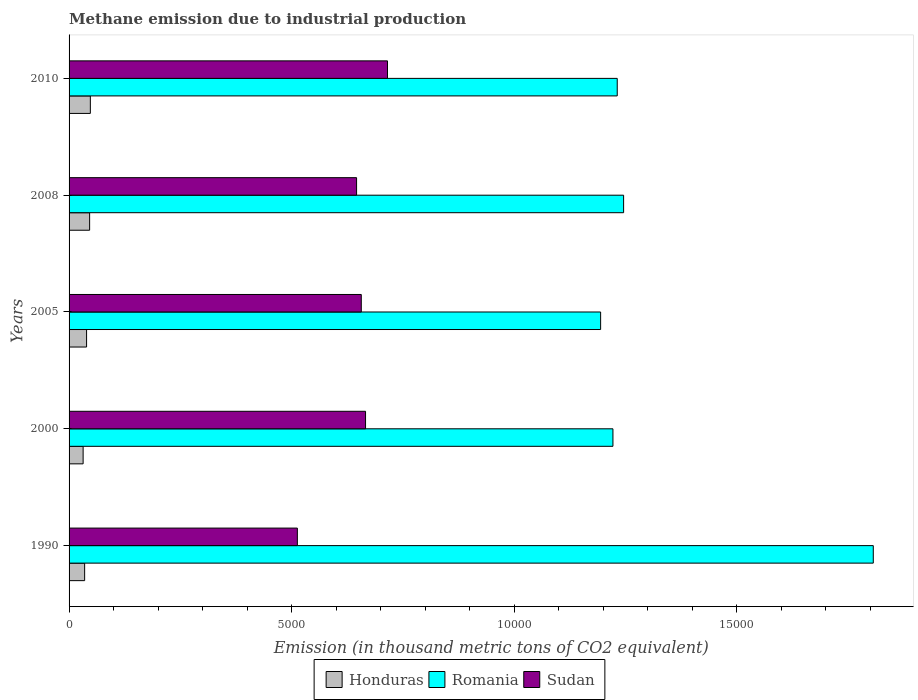How many different coloured bars are there?
Your answer should be compact. 3. Are the number of bars per tick equal to the number of legend labels?
Offer a very short reply. Yes. How many bars are there on the 5th tick from the bottom?
Your response must be concise. 3. What is the amount of methane emitted in Romania in 2010?
Give a very brief answer. 1.23e+04. Across all years, what is the maximum amount of methane emitted in Honduras?
Offer a terse response. 478.1. Across all years, what is the minimum amount of methane emitted in Honduras?
Give a very brief answer. 315.9. In which year was the amount of methane emitted in Romania minimum?
Your answer should be compact. 2005. What is the total amount of methane emitted in Sudan in the graph?
Provide a short and direct response. 3.20e+04. What is the difference between the amount of methane emitted in Honduras in 2000 and that in 2010?
Ensure brevity in your answer.  -162.2. What is the difference between the amount of methane emitted in Honduras in 2010 and the amount of methane emitted in Sudan in 2000?
Your answer should be very brief. -6182.8. What is the average amount of methane emitted in Romania per year?
Ensure brevity in your answer.  1.34e+04. In the year 2008, what is the difference between the amount of methane emitted in Sudan and amount of methane emitted in Romania?
Your answer should be compact. -5999.4. In how many years, is the amount of methane emitted in Sudan greater than 5000 thousand metric tons?
Your response must be concise. 5. What is the ratio of the amount of methane emitted in Honduras in 2005 to that in 2010?
Your answer should be compact. 0.82. Is the difference between the amount of methane emitted in Sudan in 2005 and 2010 greater than the difference between the amount of methane emitted in Romania in 2005 and 2010?
Give a very brief answer. No. What is the difference between the highest and the second highest amount of methane emitted in Romania?
Ensure brevity in your answer.  5609.2. What is the difference between the highest and the lowest amount of methane emitted in Sudan?
Ensure brevity in your answer.  2025. In how many years, is the amount of methane emitted in Romania greater than the average amount of methane emitted in Romania taken over all years?
Provide a short and direct response. 1. What does the 2nd bar from the top in 1990 represents?
Keep it short and to the point. Romania. What does the 3rd bar from the bottom in 2005 represents?
Your response must be concise. Sudan. Are all the bars in the graph horizontal?
Keep it short and to the point. Yes. What is the difference between two consecutive major ticks on the X-axis?
Ensure brevity in your answer.  5000. Are the values on the major ticks of X-axis written in scientific E-notation?
Provide a short and direct response. No. Does the graph contain grids?
Ensure brevity in your answer.  No. Where does the legend appear in the graph?
Your answer should be compact. Bottom center. How many legend labels are there?
Offer a very short reply. 3. How are the legend labels stacked?
Your answer should be compact. Horizontal. What is the title of the graph?
Your answer should be compact. Methane emission due to industrial production. What is the label or title of the X-axis?
Offer a terse response. Emission (in thousand metric tons of CO2 equivalent). What is the label or title of the Y-axis?
Your answer should be very brief. Years. What is the Emission (in thousand metric tons of CO2 equivalent) of Honduras in 1990?
Make the answer very short. 349.7. What is the Emission (in thousand metric tons of CO2 equivalent) in Romania in 1990?
Give a very brief answer. 1.81e+04. What is the Emission (in thousand metric tons of CO2 equivalent) of Sudan in 1990?
Your response must be concise. 5129.1. What is the Emission (in thousand metric tons of CO2 equivalent) in Honduras in 2000?
Your answer should be compact. 315.9. What is the Emission (in thousand metric tons of CO2 equivalent) of Romania in 2000?
Your answer should be compact. 1.22e+04. What is the Emission (in thousand metric tons of CO2 equivalent) in Sudan in 2000?
Offer a terse response. 6660.9. What is the Emission (in thousand metric tons of CO2 equivalent) of Honduras in 2005?
Your answer should be compact. 393.2. What is the Emission (in thousand metric tons of CO2 equivalent) of Romania in 2005?
Offer a very short reply. 1.19e+04. What is the Emission (in thousand metric tons of CO2 equivalent) in Sudan in 2005?
Your response must be concise. 6565.1. What is the Emission (in thousand metric tons of CO2 equivalent) of Honduras in 2008?
Provide a short and direct response. 461.7. What is the Emission (in thousand metric tons of CO2 equivalent) of Romania in 2008?
Your response must be concise. 1.25e+04. What is the Emission (in thousand metric tons of CO2 equivalent) in Sudan in 2008?
Your answer should be compact. 6459.5. What is the Emission (in thousand metric tons of CO2 equivalent) in Honduras in 2010?
Make the answer very short. 478.1. What is the Emission (in thousand metric tons of CO2 equivalent) in Romania in 2010?
Offer a very short reply. 1.23e+04. What is the Emission (in thousand metric tons of CO2 equivalent) in Sudan in 2010?
Keep it short and to the point. 7154.1. Across all years, what is the maximum Emission (in thousand metric tons of CO2 equivalent) of Honduras?
Give a very brief answer. 478.1. Across all years, what is the maximum Emission (in thousand metric tons of CO2 equivalent) in Romania?
Your answer should be very brief. 1.81e+04. Across all years, what is the maximum Emission (in thousand metric tons of CO2 equivalent) in Sudan?
Provide a short and direct response. 7154.1. Across all years, what is the minimum Emission (in thousand metric tons of CO2 equivalent) in Honduras?
Provide a succinct answer. 315.9. Across all years, what is the minimum Emission (in thousand metric tons of CO2 equivalent) of Romania?
Your answer should be very brief. 1.19e+04. Across all years, what is the minimum Emission (in thousand metric tons of CO2 equivalent) in Sudan?
Make the answer very short. 5129.1. What is the total Emission (in thousand metric tons of CO2 equivalent) of Honduras in the graph?
Your response must be concise. 1998.6. What is the total Emission (in thousand metric tons of CO2 equivalent) of Romania in the graph?
Offer a terse response. 6.70e+04. What is the total Emission (in thousand metric tons of CO2 equivalent) in Sudan in the graph?
Your answer should be very brief. 3.20e+04. What is the difference between the Emission (in thousand metric tons of CO2 equivalent) of Honduras in 1990 and that in 2000?
Provide a short and direct response. 33.8. What is the difference between the Emission (in thousand metric tons of CO2 equivalent) of Romania in 1990 and that in 2000?
Offer a terse response. 5849.1. What is the difference between the Emission (in thousand metric tons of CO2 equivalent) of Sudan in 1990 and that in 2000?
Provide a succinct answer. -1531.8. What is the difference between the Emission (in thousand metric tons of CO2 equivalent) of Honduras in 1990 and that in 2005?
Your response must be concise. -43.5. What is the difference between the Emission (in thousand metric tons of CO2 equivalent) in Romania in 1990 and that in 2005?
Keep it short and to the point. 6125.7. What is the difference between the Emission (in thousand metric tons of CO2 equivalent) in Sudan in 1990 and that in 2005?
Make the answer very short. -1436. What is the difference between the Emission (in thousand metric tons of CO2 equivalent) of Honduras in 1990 and that in 2008?
Offer a very short reply. -112. What is the difference between the Emission (in thousand metric tons of CO2 equivalent) in Romania in 1990 and that in 2008?
Make the answer very short. 5609.2. What is the difference between the Emission (in thousand metric tons of CO2 equivalent) in Sudan in 1990 and that in 2008?
Your response must be concise. -1330.4. What is the difference between the Emission (in thousand metric tons of CO2 equivalent) of Honduras in 1990 and that in 2010?
Keep it short and to the point. -128.4. What is the difference between the Emission (in thousand metric tons of CO2 equivalent) of Romania in 1990 and that in 2010?
Your answer should be compact. 5752.5. What is the difference between the Emission (in thousand metric tons of CO2 equivalent) in Sudan in 1990 and that in 2010?
Give a very brief answer. -2025. What is the difference between the Emission (in thousand metric tons of CO2 equivalent) of Honduras in 2000 and that in 2005?
Give a very brief answer. -77.3. What is the difference between the Emission (in thousand metric tons of CO2 equivalent) of Romania in 2000 and that in 2005?
Provide a short and direct response. 276.6. What is the difference between the Emission (in thousand metric tons of CO2 equivalent) of Sudan in 2000 and that in 2005?
Offer a terse response. 95.8. What is the difference between the Emission (in thousand metric tons of CO2 equivalent) of Honduras in 2000 and that in 2008?
Provide a short and direct response. -145.8. What is the difference between the Emission (in thousand metric tons of CO2 equivalent) in Romania in 2000 and that in 2008?
Make the answer very short. -239.9. What is the difference between the Emission (in thousand metric tons of CO2 equivalent) of Sudan in 2000 and that in 2008?
Keep it short and to the point. 201.4. What is the difference between the Emission (in thousand metric tons of CO2 equivalent) in Honduras in 2000 and that in 2010?
Offer a terse response. -162.2. What is the difference between the Emission (in thousand metric tons of CO2 equivalent) of Romania in 2000 and that in 2010?
Your answer should be very brief. -96.6. What is the difference between the Emission (in thousand metric tons of CO2 equivalent) of Sudan in 2000 and that in 2010?
Your answer should be compact. -493.2. What is the difference between the Emission (in thousand metric tons of CO2 equivalent) of Honduras in 2005 and that in 2008?
Give a very brief answer. -68.5. What is the difference between the Emission (in thousand metric tons of CO2 equivalent) in Romania in 2005 and that in 2008?
Your answer should be compact. -516.5. What is the difference between the Emission (in thousand metric tons of CO2 equivalent) in Sudan in 2005 and that in 2008?
Your response must be concise. 105.6. What is the difference between the Emission (in thousand metric tons of CO2 equivalent) in Honduras in 2005 and that in 2010?
Ensure brevity in your answer.  -84.9. What is the difference between the Emission (in thousand metric tons of CO2 equivalent) in Romania in 2005 and that in 2010?
Your answer should be very brief. -373.2. What is the difference between the Emission (in thousand metric tons of CO2 equivalent) in Sudan in 2005 and that in 2010?
Your response must be concise. -589. What is the difference between the Emission (in thousand metric tons of CO2 equivalent) of Honduras in 2008 and that in 2010?
Your answer should be compact. -16.4. What is the difference between the Emission (in thousand metric tons of CO2 equivalent) in Romania in 2008 and that in 2010?
Your answer should be very brief. 143.3. What is the difference between the Emission (in thousand metric tons of CO2 equivalent) of Sudan in 2008 and that in 2010?
Your answer should be compact. -694.6. What is the difference between the Emission (in thousand metric tons of CO2 equivalent) in Honduras in 1990 and the Emission (in thousand metric tons of CO2 equivalent) in Romania in 2000?
Provide a short and direct response. -1.19e+04. What is the difference between the Emission (in thousand metric tons of CO2 equivalent) of Honduras in 1990 and the Emission (in thousand metric tons of CO2 equivalent) of Sudan in 2000?
Ensure brevity in your answer.  -6311.2. What is the difference between the Emission (in thousand metric tons of CO2 equivalent) of Romania in 1990 and the Emission (in thousand metric tons of CO2 equivalent) of Sudan in 2000?
Keep it short and to the point. 1.14e+04. What is the difference between the Emission (in thousand metric tons of CO2 equivalent) of Honduras in 1990 and the Emission (in thousand metric tons of CO2 equivalent) of Romania in 2005?
Ensure brevity in your answer.  -1.16e+04. What is the difference between the Emission (in thousand metric tons of CO2 equivalent) in Honduras in 1990 and the Emission (in thousand metric tons of CO2 equivalent) in Sudan in 2005?
Ensure brevity in your answer.  -6215.4. What is the difference between the Emission (in thousand metric tons of CO2 equivalent) of Romania in 1990 and the Emission (in thousand metric tons of CO2 equivalent) of Sudan in 2005?
Provide a short and direct response. 1.15e+04. What is the difference between the Emission (in thousand metric tons of CO2 equivalent) of Honduras in 1990 and the Emission (in thousand metric tons of CO2 equivalent) of Romania in 2008?
Offer a terse response. -1.21e+04. What is the difference between the Emission (in thousand metric tons of CO2 equivalent) in Honduras in 1990 and the Emission (in thousand metric tons of CO2 equivalent) in Sudan in 2008?
Make the answer very short. -6109.8. What is the difference between the Emission (in thousand metric tons of CO2 equivalent) of Romania in 1990 and the Emission (in thousand metric tons of CO2 equivalent) of Sudan in 2008?
Provide a succinct answer. 1.16e+04. What is the difference between the Emission (in thousand metric tons of CO2 equivalent) in Honduras in 1990 and the Emission (in thousand metric tons of CO2 equivalent) in Romania in 2010?
Provide a succinct answer. -1.20e+04. What is the difference between the Emission (in thousand metric tons of CO2 equivalent) of Honduras in 1990 and the Emission (in thousand metric tons of CO2 equivalent) of Sudan in 2010?
Make the answer very short. -6804.4. What is the difference between the Emission (in thousand metric tons of CO2 equivalent) of Romania in 1990 and the Emission (in thousand metric tons of CO2 equivalent) of Sudan in 2010?
Keep it short and to the point. 1.09e+04. What is the difference between the Emission (in thousand metric tons of CO2 equivalent) of Honduras in 2000 and the Emission (in thousand metric tons of CO2 equivalent) of Romania in 2005?
Make the answer very short. -1.16e+04. What is the difference between the Emission (in thousand metric tons of CO2 equivalent) in Honduras in 2000 and the Emission (in thousand metric tons of CO2 equivalent) in Sudan in 2005?
Make the answer very short. -6249.2. What is the difference between the Emission (in thousand metric tons of CO2 equivalent) of Romania in 2000 and the Emission (in thousand metric tons of CO2 equivalent) of Sudan in 2005?
Your answer should be compact. 5653.9. What is the difference between the Emission (in thousand metric tons of CO2 equivalent) of Honduras in 2000 and the Emission (in thousand metric tons of CO2 equivalent) of Romania in 2008?
Your answer should be very brief. -1.21e+04. What is the difference between the Emission (in thousand metric tons of CO2 equivalent) in Honduras in 2000 and the Emission (in thousand metric tons of CO2 equivalent) in Sudan in 2008?
Provide a succinct answer. -6143.6. What is the difference between the Emission (in thousand metric tons of CO2 equivalent) of Romania in 2000 and the Emission (in thousand metric tons of CO2 equivalent) of Sudan in 2008?
Ensure brevity in your answer.  5759.5. What is the difference between the Emission (in thousand metric tons of CO2 equivalent) in Honduras in 2000 and the Emission (in thousand metric tons of CO2 equivalent) in Romania in 2010?
Your answer should be compact. -1.20e+04. What is the difference between the Emission (in thousand metric tons of CO2 equivalent) of Honduras in 2000 and the Emission (in thousand metric tons of CO2 equivalent) of Sudan in 2010?
Offer a very short reply. -6838.2. What is the difference between the Emission (in thousand metric tons of CO2 equivalent) of Romania in 2000 and the Emission (in thousand metric tons of CO2 equivalent) of Sudan in 2010?
Offer a terse response. 5064.9. What is the difference between the Emission (in thousand metric tons of CO2 equivalent) in Honduras in 2005 and the Emission (in thousand metric tons of CO2 equivalent) in Romania in 2008?
Provide a short and direct response. -1.21e+04. What is the difference between the Emission (in thousand metric tons of CO2 equivalent) of Honduras in 2005 and the Emission (in thousand metric tons of CO2 equivalent) of Sudan in 2008?
Your answer should be very brief. -6066.3. What is the difference between the Emission (in thousand metric tons of CO2 equivalent) of Romania in 2005 and the Emission (in thousand metric tons of CO2 equivalent) of Sudan in 2008?
Your answer should be compact. 5482.9. What is the difference between the Emission (in thousand metric tons of CO2 equivalent) of Honduras in 2005 and the Emission (in thousand metric tons of CO2 equivalent) of Romania in 2010?
Your answer should be compact. -1.19e+04. What is the difference between the Emission (in thousand metric tons of CO2 equivalent) in Honduras in 2005 and the Emission (in thousand metric tons of CO2 equivalent) in Sudan in 2010?
Your answer should be very brief. -6760.9. What is the difference between the Emission (in thousand metric tons of CO2 equivalent) in Romania in 2005 and the Emission (in thousand metric tons of CO2 equivalent) in Sudan in 2010?
Provide a succinct answer. 4788.3. What is the difference between the Emission (in thousand metric tons of CO2 equivalent) in Honduras in 2008 and the Emission (in thousand metric tons of CO2 equivalent) in Romania in 2010?
Your response must be concise. -1.19e+04. What is the difference between the Emission (in thousand metric tons of CO2 equivalent) in Honduras in 2008 and the Emission (in thousand metric tons of CO2 equivalent) in Sudan in 2010?
Offer a very short reply. -6692.4. What is the difference between the Emission (in thousand metric tons of CO2 equivalent) of Romania in 2008 and the Emission (in thousand metric tons of CO2 equivalent) of Sudan in 2010?
Your response must be concise. 5304.8. What is the average Emission (in thousand metric tons of CO2 equivalent) of Honduras per year?
Give a very brief answer. 399.72. What is the average Emission (in thousand metric tons of CO2 equivalent) in Romania per year?
Give a very brief answer. 1.34e+04. What is the average Emission (in thousand metric tons of CO2 equivalent) of Sudan per year?
Your response must be concise. 6393.74. In the year 1990, what is the difference between the Emission (in thousand metric tons of CO2 equivalent) of Honduras and Emission (in thousand metric tons of CO2 equivalent) of Romania?
Your answer should be very brief. -1.77e+04. In the year 1990, what is the difference between the Emission (in thousand metric tons of CO2 equivalent) in Honduras and Emission (in thousand metric tons of CO2 equivalent) in Sudan?
Your answer should be very brief. -4779.4. In the year 1990, what is the difference between the Emission (in thousand metric tons of CO2 equivalent) of Romania and Emission (in thousand metric tons of CO2 equivalent) of Sudan?
Offer a terse response. 1.29e+04. In the year 2000, what is the difference between the Emission (in thousand metric tons of CO2 equivalent) of Honduras and Emission (in thousand metric tons of CO2 equivalent) of Romania?
Provide a succinct answer. -1.19e+04. In the year 2000, what is the difference between the Emission (in thousand metric tons of CO2 equivalent) in Honduras and Emission (in thousand metric tons of CO2 equivalent) in Sudan?
Your answer should be compact. -6345. In the year 2000, what is the difference between the Emission (in thousand metric tons of CO2 equivalent) of Romania and Emission (in thousand metric tons of CO2 equivalent) of Sudan?
Offer a very short reply. 5558.1. In the year 2005, what is the difference between the Emission (in thousand metric tons of CO2 equivalent) of Honduras and Emission (in thousand metric tons of CO2 equivalent) of Romania?
Your answer should be very brief. -1.15e+04. In the year 2005, what is the difference between the Emission (in thousand metric tons of CO2 equivalent) of Honduras and Emission (in thousand metric tons of CO2 equivalent) of Sudan?
Ensure brevity in your answer.  -6171.9. In the year 2005, what is the difference between the Emission (in thousand metric tons of CO2 equivalent) in Romania and Emission (in thousand metric tons of CO2 equivalent) in Sudan?
Your answer should be compact. 5377.3. In the year 2008, what is the difference between the Emission (in thousand metric tons of CO2 equivalent) of Honduras and Emission (in thousand metric tons of CO2 equivalent) of Romania?
Your answer should be compact. -1.20e+04. In the year 2008, what is the difference between the Emission (in thousand metric tons of CO2 equivalent) in Honduras and Emission (in thousand metric tons of CO2 equivalent) in Sudan?
Ensure brevity in your answer.  -5997.8. In the year 2008, what is the difference between the Emission (in thousand metric tons of CO2 equivalent) of Romania and Emission (in thousand metric tons of CO2 equivalent) of Sudan?
Make the answer very short. 5999.4. In the year 2010, what is the difference between the Emission (in thousand metric tons of CO2 equivalent) in Honduras and Emission (in thousand metric tons of CO2 equivalent) in Romania?
Give a very brief answer. -1.18e+04. In the year 2010, what is the difference between the Emission (in thousand metric tons of CO2 equivalent) of Honduras and Emission (in thousand metric tons of CO2 equivalent) of Sudan?
Your answer should be very brief. -6676. In the year 2010, what is the difference between the Emission (in thousand metric tons of CO2 equivalent) of Romania and Emission (in thousand metric tons of CO2 equivalent) of Sudan?
Your answer should be very brief. 5161.5. What is the ratio of the Emission (in thousand metric tons of CO2 equivalent) of Honduras in 1990 to that in 2000?
Your answer should be very brief. 1.11. What is the ratio of the Emission (in thousand metric tons of CO2 equivalent) in Romania in 1990 to that in 2000?
Your answer should be very brief. 1.48. What is the ratio of the Emission (in thousand metric tons of CO2 equivalent) of Sudan in 1990 to that in 2000?
Offer a terse response. 0.77. What is the ratio of the Emission (in thousand metric tons of CO2 equivalent) in Honduras in 1990 to that in 2005?
Provide a short and direct response. 0.89. What is the ratio of the Emission (in thousand metric tons of CO2 equivalent) in Romania in 1990 to that in 2005?
Keep it short and to the point. 1.51. What is the ratio of the Emission (in thousand metric tons of CO2 equivalent) in Sudan in 1990 to that in 2005?
Your response must be concise. 0.78. What is the ratio of the Emission (in thousand metric tons of CO2 equivalent) of Honduras in 1990 to that in 2008?
Your answer should be compact. 0.76. What is the ratio of the Emission (in thousand metric tons of CO2 equivalent) in Romania in 1990 to that in 2008?
Make the answer very short. 1.45. What is the ratio of the Emission (in thousand metric tons of CO2 equivalent) in Sudan in 1990 to that in 2008?
Keep it short and to the point. 0.79. What is the ratio of the Emission (in thousand metric tons of CO2 equivalent) in Honduras in 1990 to that in 2010?
Provide a succinct answer. 0.73. What is the ratio of the Emission (in thousand metric tons of CO2 equivalent) in Romania in 1990 to that in 2010?
Provide a short and direct response. 1.47. What is the ratio of the Emission (in thousand metric tons of CO2 equivalent) in Sudan in 1990 to that in 2010?
Provide a short and direct response. 0.72. What is the ratio of the Emission (in thousand metric tons of CO2 equivalent) of Honduras in 2000 to that in 2005?
Ensure brevity in your answer.  0.8. What is the ratio of the Emission (in thousand metric tons of CO2 equivalent) in Romania in 2000 to that in 2005?
Ensure brevity in your answer.  1.02. What is the ratio of the Emission (in thousand metric tons of CO2 equivalent) in Sudan in 2000 to that in 2005?
Provide a short and direct response. 1.01. What is the ratio of the Emission (in thousand metric tons of CO2 equivalent) in Honduras in 2000 to that in 2008?
Provide a short and direct response. 0.68. What is the ratio of the Emission (in thousand metric tons of CO2 equivalent) in Romania in 2000 to that in 2008?
Offer a very short reply. 0.98. What is the ratio of the Emission (in thousand metric tons of CO2 equivalent) in Sudan in 2000 to that in 2008?
Keep it short and to the point. 1.03. What is the ratio of the Emission (in thousand metric tons of CO2 equivalent) of Honduras in 2000 to that in 2010?
Offer a terse response. 0.66. What is the ratio of the Emission (in thousand metric tons of CO2 equivalent) of Romania in 2000 to that in 2010?
Provide a succinct answer. 0.99. What is the ratio of the Emission (in thousand metric tons of CO2 equivalent) of Sudan in 2000 to that in 2010?
Make the answer very short. 0.93. What is the ratio of the Emission (in thousand metric tons of CO2 equivalent) in Honduras in 2005 to that in 2008?
Your answer should be compact. 0.85. What is the ratio of the Emission (in thousand metric tons of CO2 equivalent) of Romania in 2005 to that in 2008?
Offer a terse response. 0.96. What is the ratio of the Emission (in thousand metric tons of CO2 equivalent) in Sudan in 2005 to that in 2008?
Give a very brief answer. 1.02. What is the ratio of the Emission (in thousand metric tons of CO2 equivalent) in Honduras in 2005 to that in 2010?
Provide a short and direct response. 0.82. What is the ratio of the Emission (in thousand metric tons of CO2 equivalent) in Romania in 2005 to that in 2010?
Give a very brief answer. 0.97. What is the ratio of the Emission (in thousand metric tons of CO2 equivalent) in Sudan in 2005 to that in 2010?
Offer a terse response. 0.92. What is the ratio of the Emission (in thousand metric tons of CO2 equivalent) in Honduras in 2008 to that in 2010?
Ensure brevity in your answer.  0.97. What is the ratio of the Emission (in thousand metric tons of CO2 equivalent) in Romania in 2008 to that in 2010?
Keep it short and to the point. 1.01. What is the ratio of the Emission (in thousand metric tons of CO2 equivalent) in Sudan in 2008 to that in 2010?
Your answer should be compact. 0.9. What is the difference between the highest and the second highest Emission (in thousand metric tons of CO2 equivalent) in Romania?
Offer a terse response. 5609.2. What is the difference between the highest and the second highest Emission (in thousand metric tons of CO2 equivalent) in Sudan?
Offer a very short reply. 493.2. What is the difference between the highest and the lowest Emission (in thousand metric tons of CO2 equivalent) of Honduras?
Provide a succinct answer. 162.2. What is the difference between the highest and the lowest Emission (in thousand metric tons of CO2 equivalent) in Romania?
Your response must be concise. 6125.7. What is the difference between the highest and the lowest Emission (in thousand metric tons of CO2 equivalent) in Sudan?
Your response must be concise. 2025. 